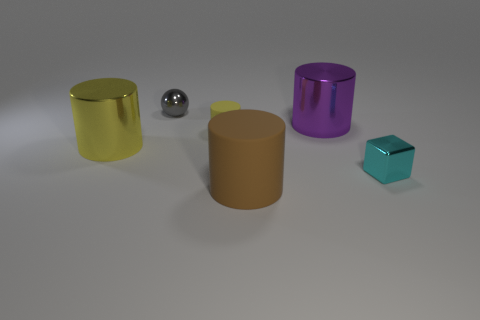There is another big matte thing that is the same shape as the large yellow thing; what color is it?
Provide a short and direct response. Brown. Is there a big shiny object of the same color as the tiny cylinder?
Offer a terse response. Yes. Is the material of the big thing that is in front of the tiny cyan metallic block the same as the cylinder to the right of the large brown matte thing?
Offer a very short reply. No. Are there any other things that have the same color as the tiny matte cylinder?
Give a very brief answer. Yes. What is the size of the cylinder in front of the tiny metallic thing that is to the right of the cylinder to the right of the brown cylinder?
Your response must be concise. Large. There is a metallic cylinder right of the large brown matte object; how big is it?
Your answer should be very brief. Large. How many tiny gray things have the same material as the brown thing?
Make the answer very short. 0. What shape is the shiny thing that is the same color as the small rubber cylinder?
Offer a terse response. Cylinder. Do the large shiny object that is on the right side of the yellow shiny thing and the large brown rubber object have the same shape?
Your answer should be very brief. Yes. What is the color of the small cube that is the same material as the large purple thing?
Your answer should be compact. Cyan. 